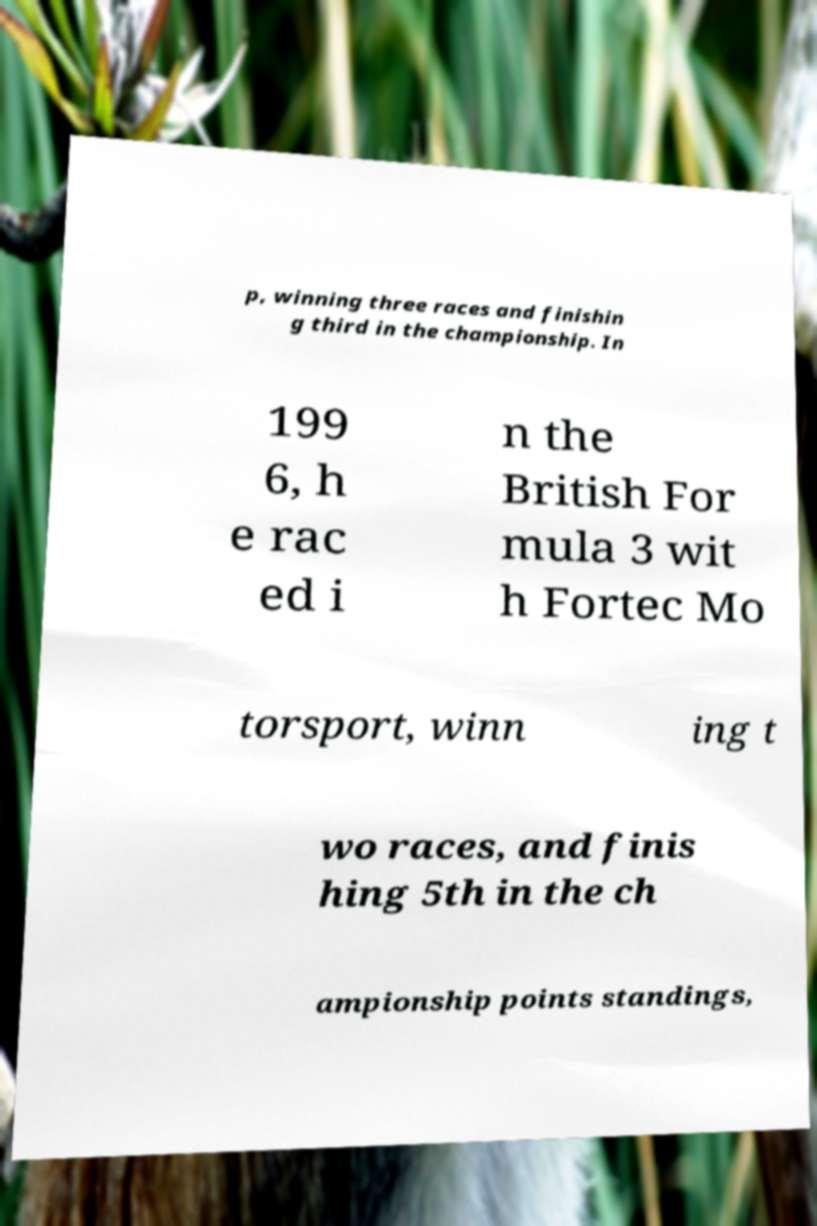Please read and relay the text visible in this image. What does it say? p, winning three races and finishin g third in the championship. In 199 6, h e rac ed i n the British For mula 3 wit h Fortec Mo torsport, winn ing t wo races, and finis hing 5th in the ch ampionship points standings, 